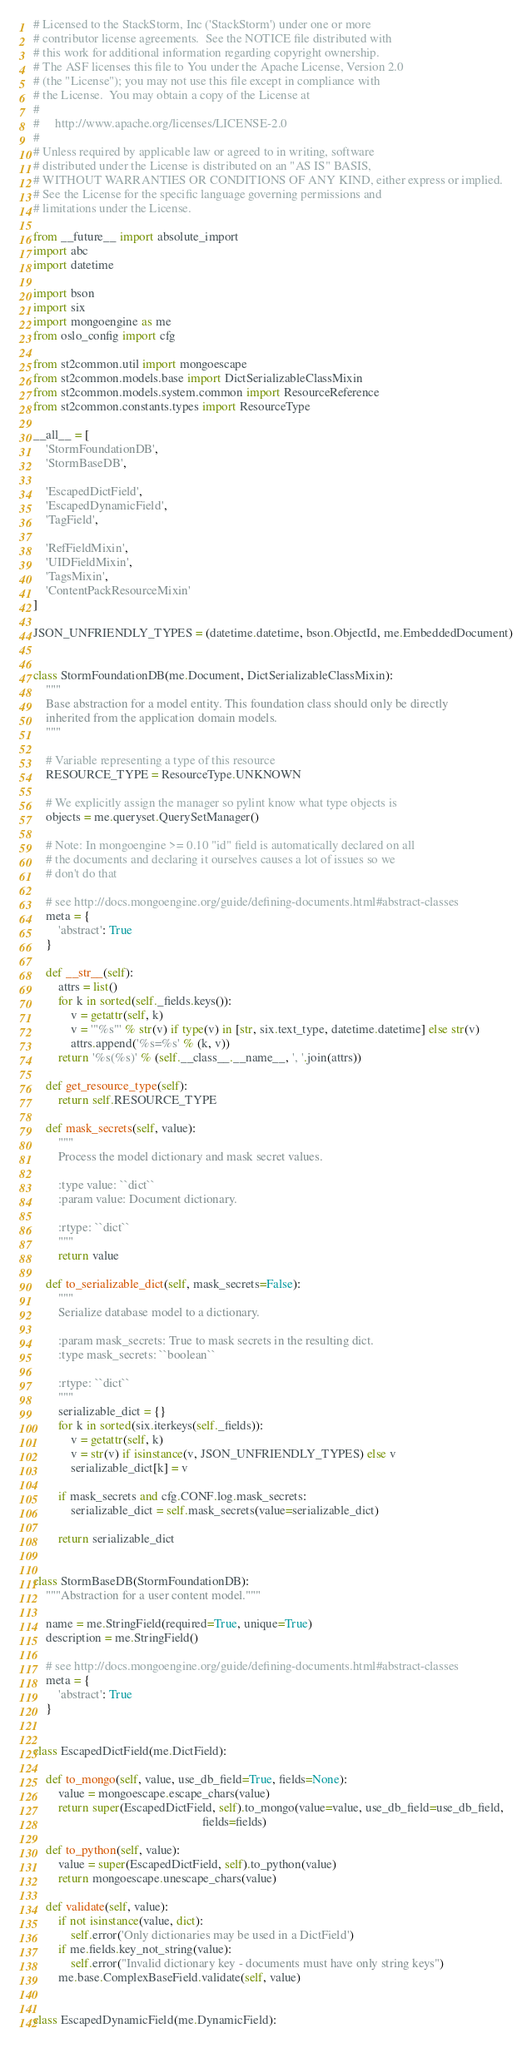<code> <loc_0><loc_0><loc_500><loc_500><_Python_># Licensed to the StackStorm, Inc ('StackStorm') under one or more
# contributor license agreements.  See the NOTICE file distributed with
# this work for additional information regarding copyright ownership.
# The ASF licenses this file to You under the Apache License, Version 2.0
# (the "License"); you may not use this file except in compliance with
# the License.  You may obtain a copy of the License at
#
#     http://www.apache.org/licenses/LICENSE-2.0
#
# Unless required by applicable law or agreed to in writing, software
# distributed under the License is distributed on an "AS IS" BASIS,
# WITHOUT WARRANTIES OR CONDITIONS OF ANY KIND, either express or implied.
# See the License for the specific language governing permissions and
# limitations under the License.

from __future__ import absolute_import
import abc
import datetime

import bson
import six
import mongoengine as me
from oslo_config import cfg

from st2common.util import mongoescape
from st2common.models.base import DictSerializableClassMixin
from st2common.models.system.common import ResourceReference
from st2common.constants.types import ResourceType

__all__ = [
    'StormFoundationDB',
    'StormBaseDB',

    'EscapedDictField',
    'EscapedDynamicField',
    'TagField',

    'RefFieldMixin',
    'UIDFieldMixin',
    'TagsMixin',
    'ContentPackResourceMixin'
]

JSON_UNFRIENDLY_TYPES = (datetime.datetime, bson.ObjectId, me.EmbeddedDocument)


class StormFoundationDB(me.Document, DictSerializableClassMixin):
    """
    Base abstraction for a model entity. This foundation class should only be directly
    inherited from the application domain models.
    """

    # Variable representing a type of this resource
    RESOURCE_TYPE = ResourceType.UNKNOWN

    # We explicitly assign the manager so pylint know what type objects is
    objects = me.queryset.QuerySetManager()

    # Note: In mongoengine >= 0.10 "id" field is automatically declared on all
    # the documents and declaring it ourselves causes a lot of issues so we
    # don't do that

    # see http://docs.mongoengine.org/guide/defining-documents.html#abstract-classes
    meta = {
        'abstract': True
    }

    def __str__(self):
        attrs = list()
        for k in sorted(self._fields.keys()):
            v = getattr(self, k)
            v = '"%s"' % str(v) if type(v) in [str, six.text_type, datetime.datetime] else str(v)
            attrs.append('%s=%s' % (k, v))
        return '%s(%s)' % (self.__class__.__name__, ', '.join(attrs))

    def get_resource_type(self):
        return self.RESOURCE_TYPE

    def mask_secrets(self, value):
        """
        Process the model dictionary and mask secret values.

        :type value: ``dict``
        :param value: Document dictionary.

        :rtype: ``dict``
        """
        return value

    def to_serializable_dict(self, mask_secrets=False):
        """
        Serialize database model to a dictionary.

        :param mask_secrets: True to mask secrets in the resulting dict.
        :type mask_secrets: ``boolean``

        :rtype: ``dict``
        """
        serializable_dict = {}
        for k in sorted(six.iterkeys(self._fields)):
            v = getattr(self, k)
            v = str(v) if isinstance(v, JSON_UNFRIENDLY_TYPES) else v
            serializable_dict[k] = v

        if mask_secrets and cfg.CONF.log.mask_secrets:
            serializable_dict = self.mask_secrets(value=serializable_dict)

        return serializable_dict


class StormBaseDB(StormFoundationDB):
    """Abstraction for a user content model."""

    name = me.StringField(required=True, unique=True)
    description = me.StringField()

    # see http://docs.mongoengine.org/guide/defining-documents.html#abstract-classes
    meta = {
        'abstract': True
    }


class EscapedDictField(me.DictField):

    def to_mongo(self, value, use_db_field=True, fields=None):
        value = mongoescape.escape_chars(value)
        return super(EscapedDictField, self).to_mongo(value=value, use_db_field=use_db_field,
                                                      fields=fields)

    def to_python(self, value):
        value = super(EscapedDictField, self).to_python(value)
        return mongoescape.unescape_chars(value)

    def validate(self, value):
        if not isinstance(value, dict):
            self.error('Only dictionaries may be used in a DictField')
        if me.fields.key_not_string(value):
            self.error("Invalid dictionary key - documents must have only string keys")
        me.base.ComplexBaseField.validate(self, value)


class EscapedDynamicField(me.DynamicField):
</code> 